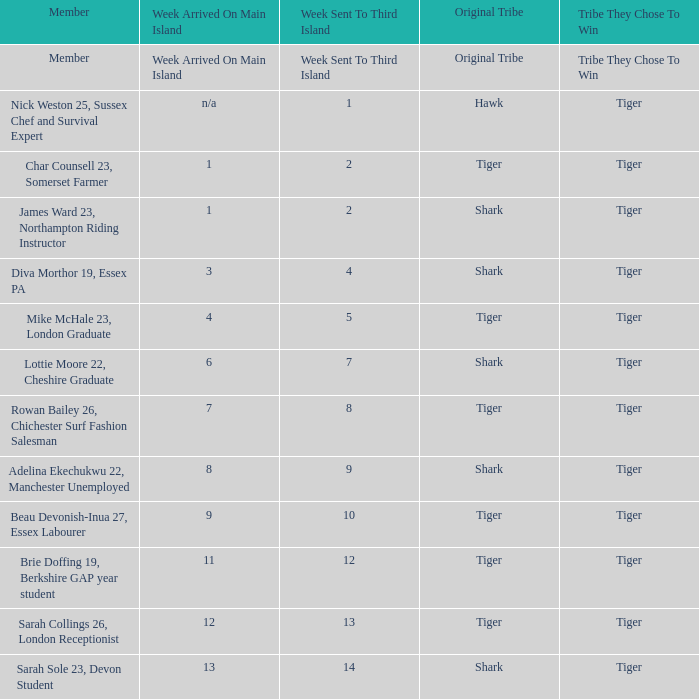In the first week, who was dispatched to the third island? Nick Weston 25, Sussex Chef and Survival Expert. 